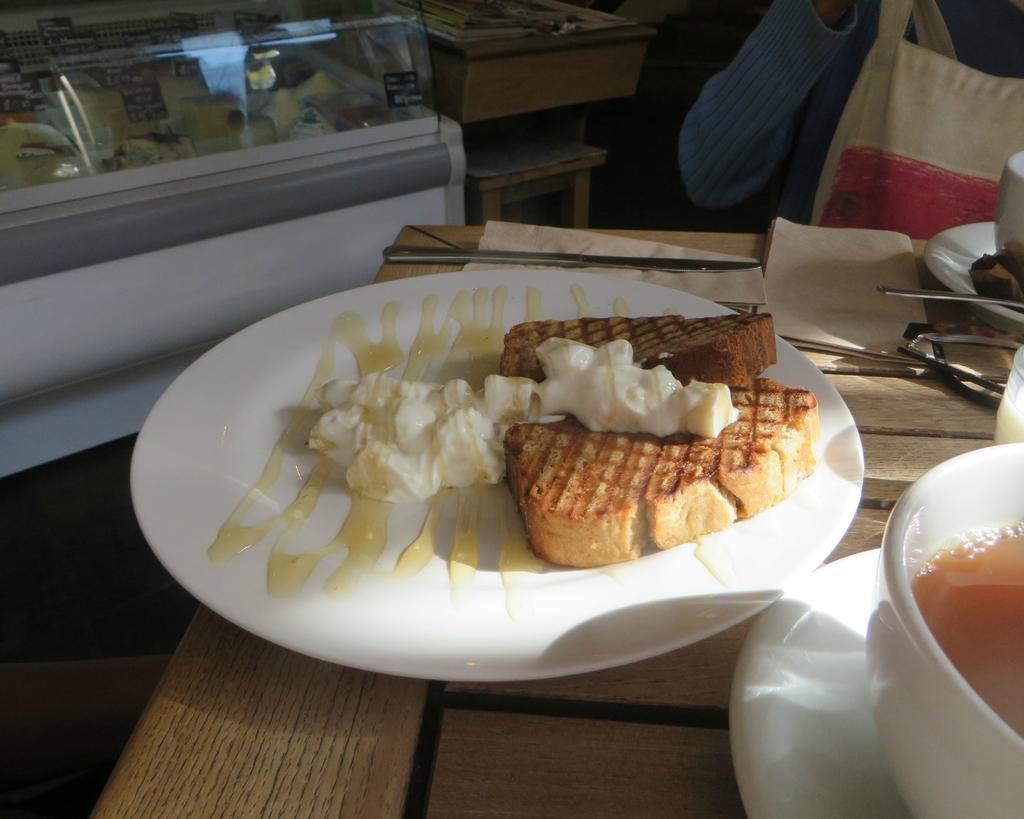Please provide a concise description of this image. In this picture we can see some food items on the plate. There are cups, saucers and other objects on the table. We can see liquid in one of the cups. We can see food items in the display refrigerator. There are some objects visible on a wooden object. We can see a stool a person and other objects. 